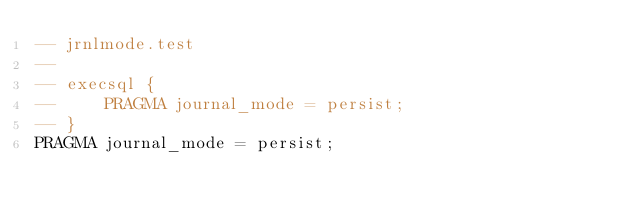Convert code to text. <code><loc_0><loc_0><loc_500><loc_500><_SQL_>-- jrnlmode.test
-- 
-- execsql {
--     PRAGMA journal_mode = persist;
-- }
PRAGMA journal_mode = persist;</code> 